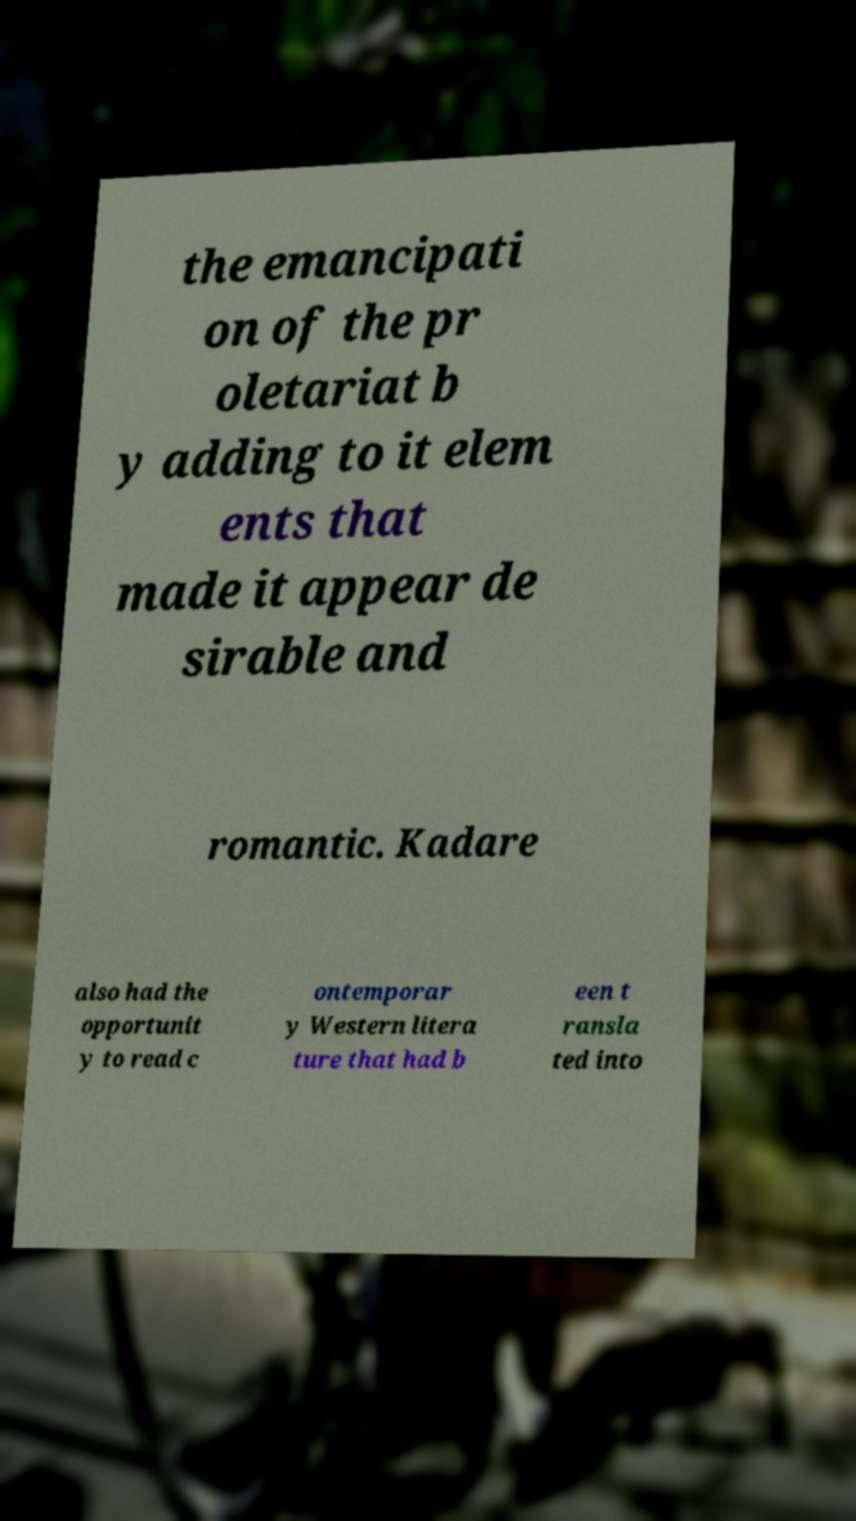Could you extract and type out the text from this image? the emancipati on of the pr oletariat b y adding to it elem ents that made it appear de sirable and romantic. Kadare also had the opportunit y to read c ontemporar y Western litera ture that had b een t ransla ted into 